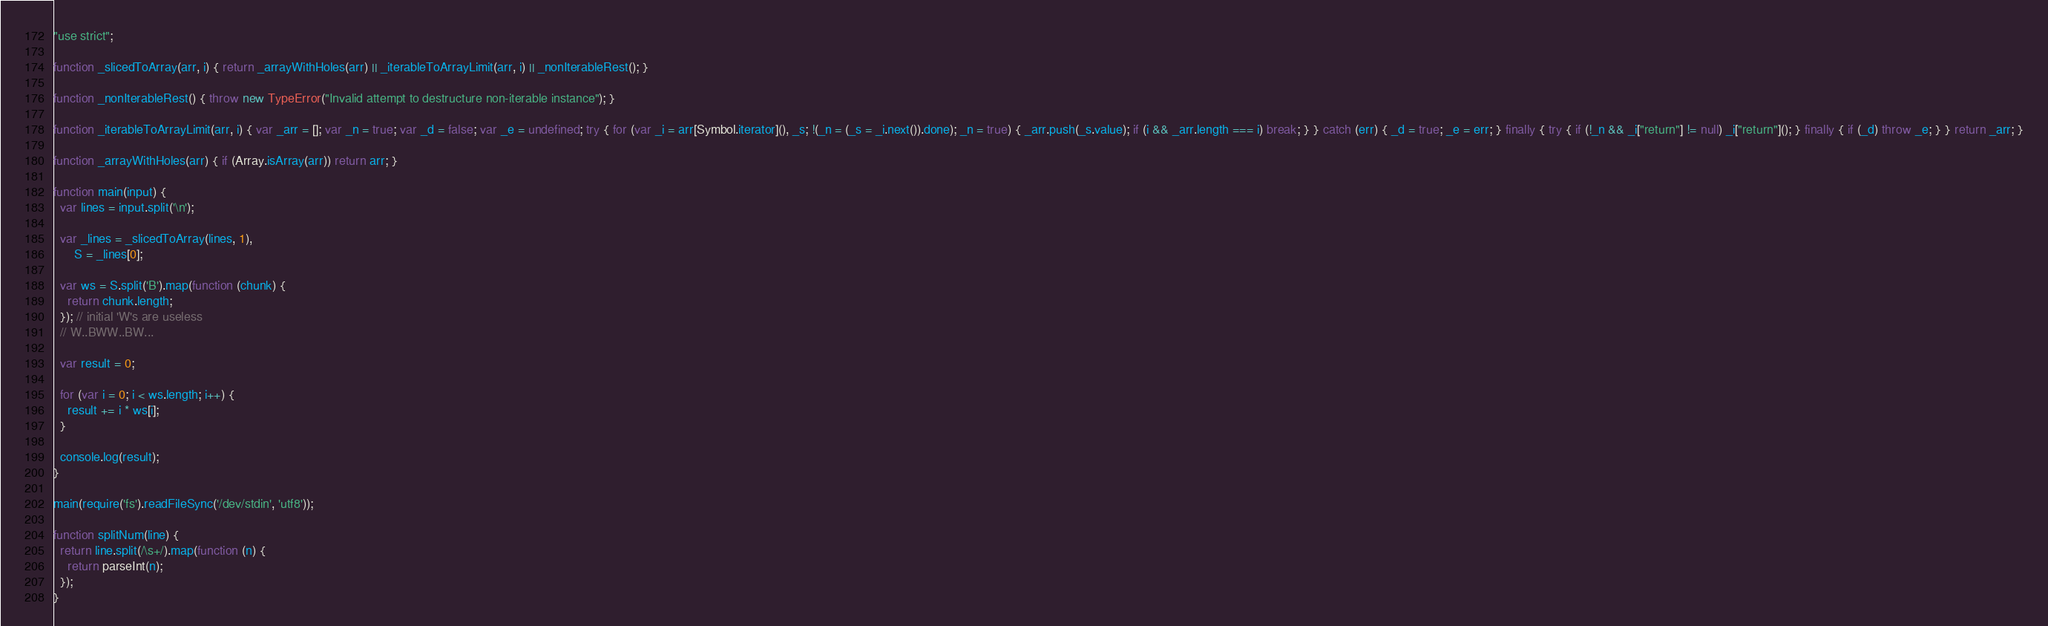<code> <loc_0><loc_0><loc_500><loc_500><_JavaScript_>"use strict";

function _slicedToArray(arr, i) { return _arrayWithHoles(arr) || _iterableToArrayLimit(arr, i) || _nonIterableRest(); }

function _nonIterableRest() { throw new TypeError("Invalid attempt to destructure non-iterable instance"); }

function _iterableToArrayLimit(arr, i) { var _arr = []; var _n = true; var _d = false; var _e = undefined; try { for (var _i = arr[Symbol.iterator](), _s; !(_n = (_s = _i.next()).done); _n = true) { _arr.push(_s.value); if (i && _arr.length === i) break; } } catch (err) { _d = true; _e = err; } finally { try { if (!_n && _i["return"] != null) _i["return"](); } finally { if (_d) throw _e; } } return _arr; }

function _arrayWithHoles(arr) { if (Array.isArray(arr)) return arr; }

function main(input) {
  var lines = input.split('\n');

  var _lines = _slicedToArray(lines, 1),
      S = _lines[0];

  var ws = S.split('B').map(function (chunk) {
    return chunk.length;
  }); // initial 'W's are useless
  // W..BWW..BW...

  var result = 0;

  for (var i = 0; i < ws.length; i++) {
    result += i * ws[i];
  }

  console.log(result);
}

main(require('fs').readFileSync('/dev/stdin', 'utf8'));

function splitNum(line) {
  return line.split(/\s+/).map(function (n) {
    return parseInt(n);
  });
}
</code> 